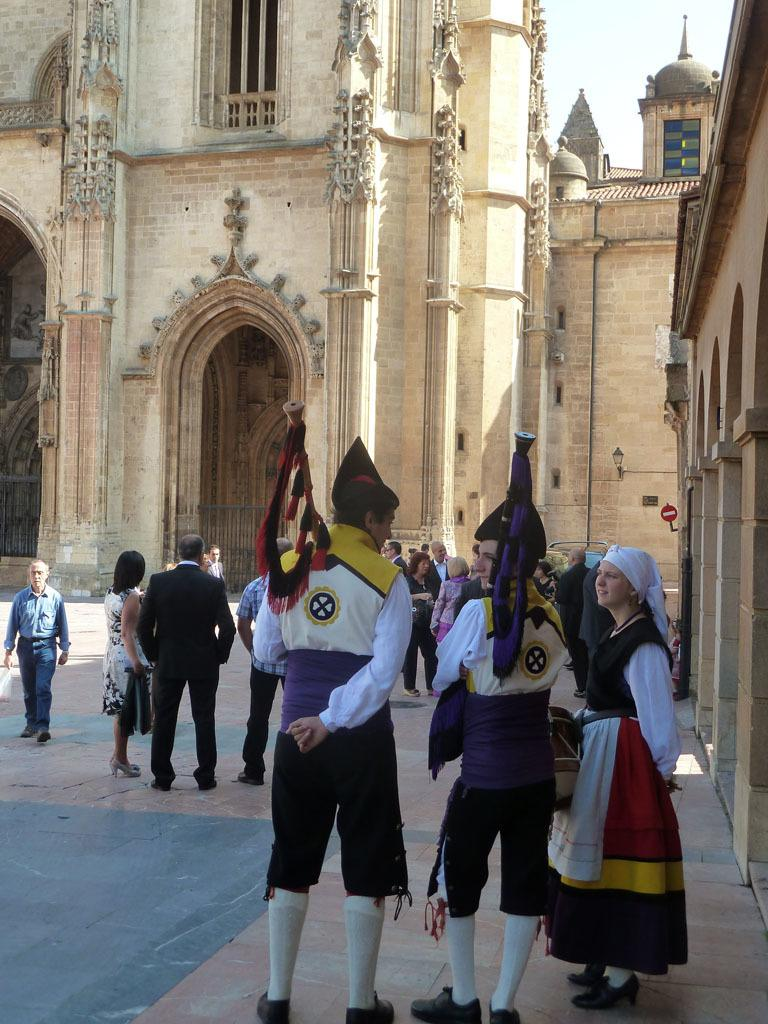What is the main subject of the image? The main subject of the image is a crowd of people. What are the people doing in the image? The people are standing on the floor. What are some people holding in their hands? Some people are holding flags in their hands. What can be seen in the background of the image? There are buildings and the sky visible in the background of the image. What news headline is being discussed by the crowd in the image? There is no news headline being discussed in the image; it only shows a crowd of people standing on the floor and holding flags. What type of baseball game is being played in the image? There is no baseball game being played in the image; it only shows a crowd of people standing on the floor and holding flags. 